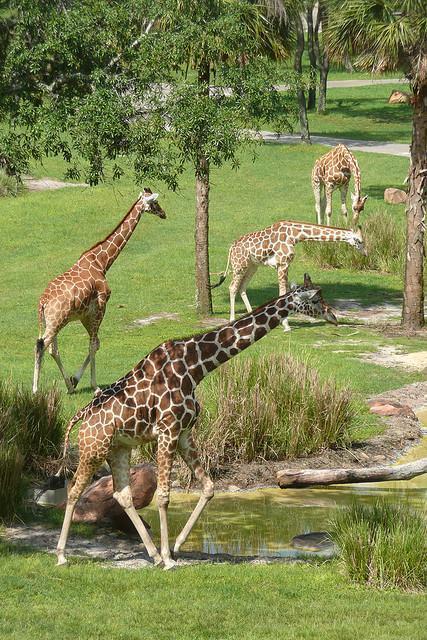How many giraffes can you see?
Give a very brief answer. 4. How many animal is in this picture?
Give a very brief answer. 4. How many giraffes can be seen?
Give a very brief answer. 4. How many people are wearing a catchers helmet in the image?
Give a very brief answer. 0. 